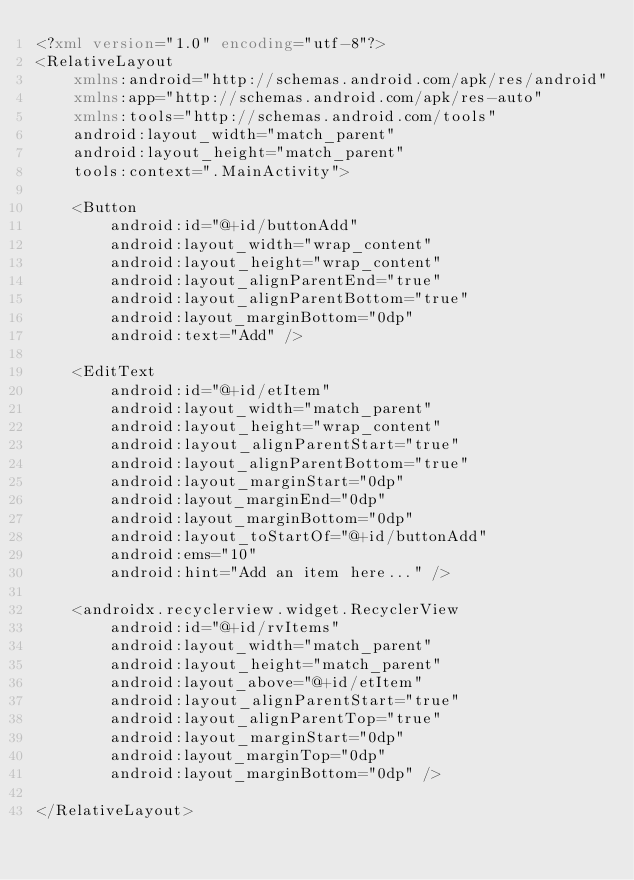Convert code to text. <code><loc_0><loc_0><loc_500><loc_500><_XML_><?xml version="1.0" encoding="utf-8"?>
<RelativeLayout
    xmlns:android="http://schemas.android.com/apk/res/android"
    xmlns:app="http://schemas.android.com/apk/res-auto"
    xmlns:tools="http://schemas.android.com/tools"
    android:layout_width="match_parent"
    android:layout_height="match_parent"
    tools:context=".MainActivity">

    <Button
        android:id="@+id/buttonAdd"
        android:layout_width="wrap_content"
        android:layout_height="wrap_content"
        android:layout_alignParentEnd="true"
        android:layout_alignParentBottom="true"
        android:layout_marginBottom="0dp"
        android:text="Add" />

    <EditText
        android:id="@+id/etItem"
        android:layout_width="match_parent"
        android:layout_height="wrap_content"
        android:layout_alignParentStart="true"
        android:layout_alignParentBottom="true"
        android:layout_marginStart="0dp"
        android:layout_marginEnd="0dp"
        android:layout_marginBottom="0dp"
        android:layout_toStartOf="@+id/buttonAdd"
        android:ems="10"
        android:hint="Add an item here..." />

    <androidx.recyclerview.widget.RecyclerView
        android:id="@+id/rvItems"
        android:layout_width="match_parent"
        android:layout_height="match_parent"
        android:layout_above="@+id/etItem"
        android:layout_alignParentStart="true"
        android:layout_alignParentTop="true"
        android:layout_marginStart="0dp"
        android:layout_marginTop="0dp"
        android:layout_marginBottom="0dp" />

</RelativeLayout></code> 